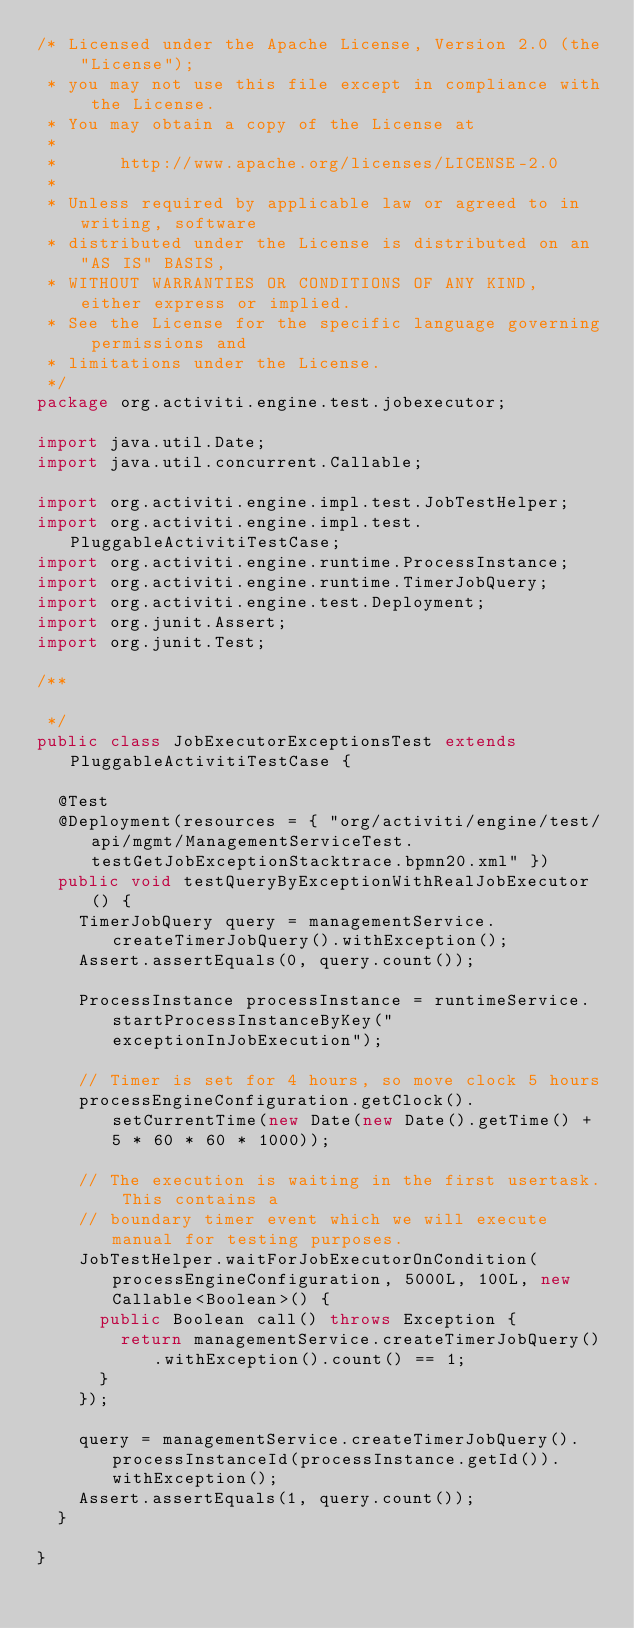<code> <loc_0><loc_0><loc_500><loc_500><_Java_>/* Licensed under the Apache License, Version 2.0 (the "License");
 * you may not use this file except in compliance with the License.
 * You may obtain a copy of the License at
 * 
 *      http://www.apache.org/licenses/LICENSE-2.0
 * 
 * Unless required by applicable law or agreed to in writing, software
 * distributed under the License is distributed on an "AS IS" BASIS,
 * WITHOUT WARRANTIES OR CONDITIONS OF ANY KIND, either express or implied.
 * See the License for the specific language governing permissions and
 * limitations under the License.
 */
package org.activiti.engine.test.jobexecutor;

import java.util.Date;
import java.util.concurrent.Callable;

import org.activiti.engine.impl.test.JobTestHelper;
import org.activiti.engine.impl.test.PluggableActivitiTestCase;
import org.activiti.engine.runtime.ProcessInstance;
import org.activiti.engine.runtime.TimerJobQuery;
import org.activiti.engine.test.Deployment;
import org.junit.Assert;
import org.junit.Test;

/**

 */
public class JobExecutorExceptionsTest extends PluggableActivitiTestCase {

  @Test
  @Deployment(resources = { "org/activiti/engine/test/api/mgmt/ManagementServiceTest.testGetJobExceptionStacktrace.bpmn20.xml" })
  public void testQueryByExceptionWithRealJobExecutor() {
    TimerJobQuery query = managementService.createTimerJobQuery().withException();
    Assert.assertEquals(0, query.count());

    ProcessInstance processInstance = runtimeService.startProcessInstanceByKey("exceptionInJobExecution");

    // Timer is set for 4 hours, so move clock 5 hours
    processEngineConfiguration.getClock().setCurrentTime(new Date(new Date().getTime() + 5 * 60 * 60 * 1000));

    // The execution is waiting in the first usertask. This contains a
    // boundary timer event which we will execute manual for testing purposes.
    JobTestHelper.waitForJobExecutorOnCondition(processEngineConfiguration, 5000L, 100L, new Callable<Boolean>() {
      public Boolean call() throws Exception {
        return managementService.createTimerJobQuery().withException().count() == 1;
      }
    });

    query = managementService.createTimerJobQuery().processInstanceId(processInstance.getId()).withException();
    Assert.assertEquals(1, query.count());
  }

}
</code> 